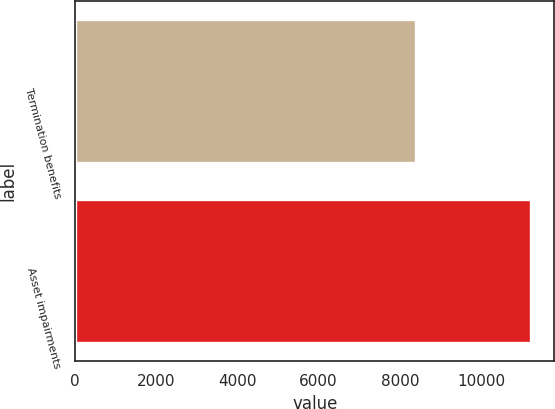<chart> <loc_0><loc_0><loc_500><loc_500><bar_chart><fcel>Termination benefits<fcel>Asset impairments<nl><fcel>8407<fcel>11244<nl></chart> 